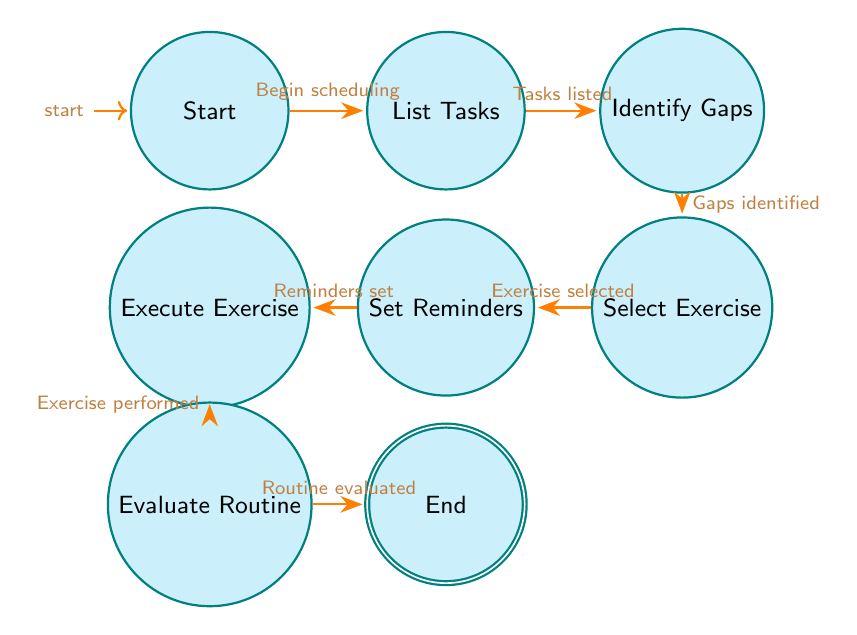What is the initial state of the diagram? The initial state is represented by the first node labeled "Start." This is the starting point for the scheduling process, where no actions have been taken yet.
Answer: Start How many states are in the diagram? The diagram has a total of eight states: Start, List Tasks, Identify Gaps, Select Exercise, Set Reminders, Execute Exercise, Evaluate Routine, and End. Counting each node gives the total states.
Answer: Eight What is the last step before reaching the end of the process? The last step before reaching the end is "Evaluate Routine." This node represents the assessment phase after all exercise breaks have been scheduled and executed.
Answer: Evaluate Routine What condition leads from "Select Exercise" to "Set Reminders"? The transition from "Select Exercise" to "Set Reminders" occurs when an exercise choice has been made, as indicated by the condition "Exercise selected" in the diagram.
Answer: Exercise selected What state follows after "Execute Exercise"? The state that follows "Execute Exercise" is "Evaluate Routine." This shows the progression from performing exercises to assessing their effectiveness.
Answer: Evaluate Routine Which transition occurs after "Identify Gaps"? The transition that occurs after "Identify Gaps" is to "Select Exercise." This indicates that once gaps in the schedule are identified, the next step is to choose a specific exercise.
Answer: Select Exercise What is the condition for moving from "Evaluate Routine" to "End"? The condition required to transition from "Evaluate Routine" to "End" is the effective evaluation of the routine, described as "Routine evaluated and adjusted" in the diagram.
Answer: Routine evaluated and adjusted Which node is the accepting state? The accepting state is "End," which signifies the completion of the process after all steps have been followed from scheduling exercise breaks to evaluating them.
Answer: End 